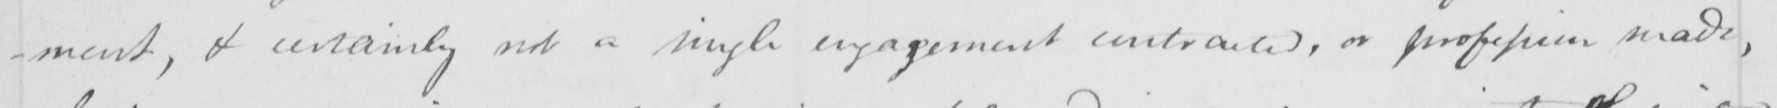What is written in this line of handwriting? -ment , & certainly not a single engagement contracted , or profession made , 